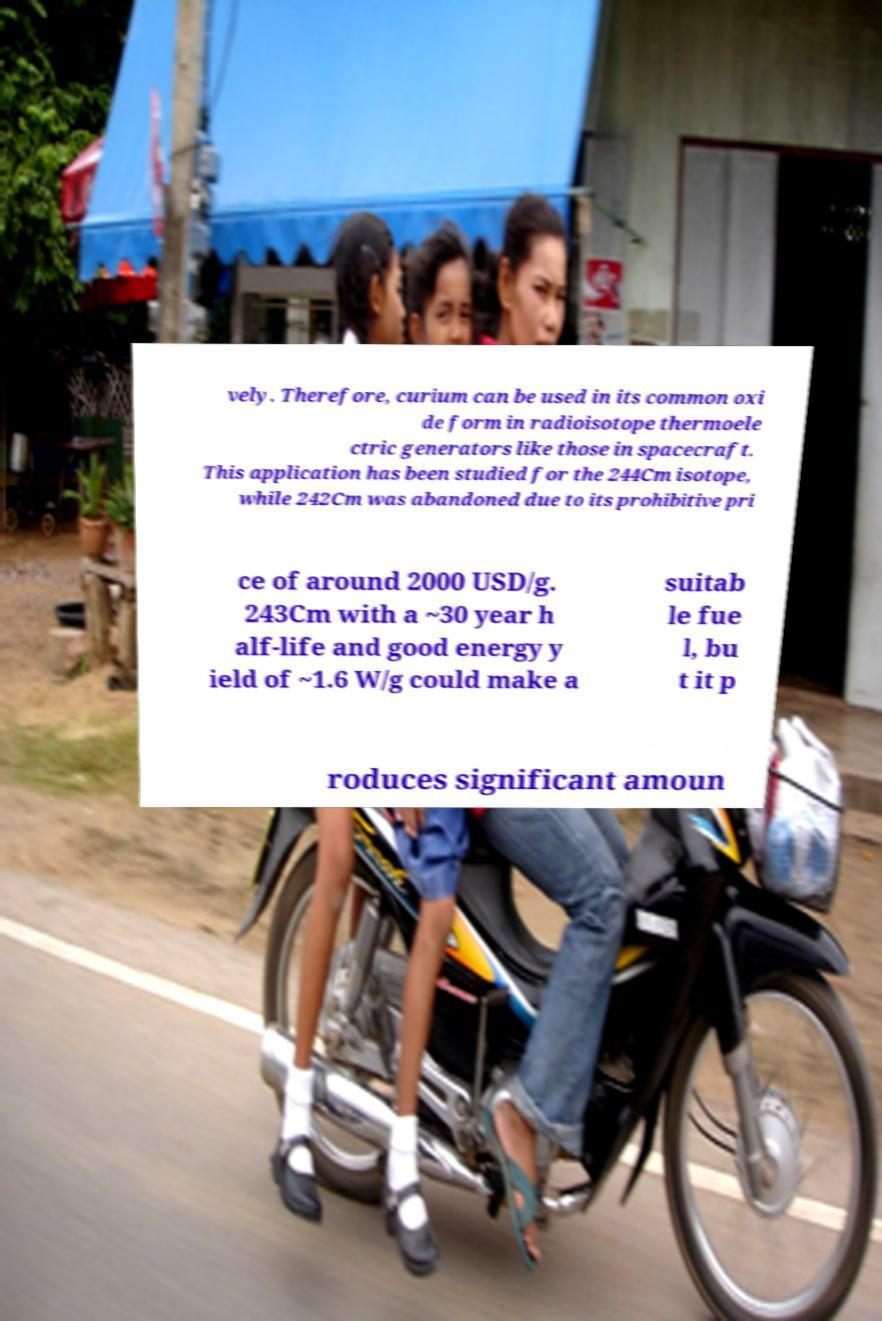For documentation purposes, I need the text within this image transcribed. Could you provide that? vely. Therefore, curium can be used in its common oxi de form in radioisotope thermoele ctric generators like those in spacecraft. This application has been studied for the 244Cm isotope, while 242Cm was abandoned due to its prohibitive pri ce of around 2000 USD/g. 243Cm with a ~30 year h alf-life and good energy y ield of ~1.6 W/g could make a suitab le fue l, bu t it p roduces significant amoun 